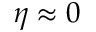Convert formula to latex. <formula><loc_0><loc_0><loc_500><loc_500>\eta \approx 0</formula> 